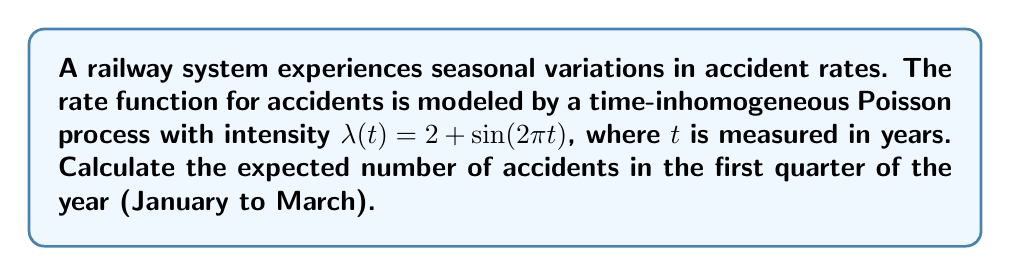What is the answer to this math problem? To solve this problem, we need to follow these steps:

1) In a time-inhomogeneous Poisson process, the expected number of events in an interval $[a,b]$ is given by:

   $$E[N(b) - N(a)] = \int_a^b \lambda(t) dt$$

2) In our case, $a = 0$ (start of the year) and $b = 0.25$ (end of first quarter). So we need to calculate:

   $$E[N(0.25) - N(0)] = \int_0^{0.25} (2 + \sin(2\pi t)) dt$$

3) Let's solve this integral:

   $$\int_0^{0.25} (2 + \sin(2\pi t)) dt = \int_0^{0.25} 2 dt + \int_0^{0.25} \sin(2\pi t) dt$$

4) The first part is straightforward:

   $$\int_0^{0.25} 2 dt = 2t \Big|_0^{0.25} = 2(0.25) - 2(0) = 0.5$$

5) For the second part:

   $$\int_0^{0.25} \sin(2\pi t) dt = -\frac{1}{2\pi} \cos(2\pi t) \Big|_0^{0.25}$$
   $$= -\frac{1}{2\pi} [\cos(2\pi(0.25)) - \cos(2\pi(0))]$$
   $$= -\frac{1}{2\pi} [\cos(\pi/2) - \cos(0)]$$
   $$= -\frac{1}{2\pi} [0 - 1] = \frac{1}{2\pi}$$

6) Adding the results from steps 4 and 5:

   $$E[N(0.25) - N(0)] = 0.5 + \frac{1}{2\pi} \approx 0.6592$$

This is the expected number of accidents in the first quarter of the year.
Answer: 0.6592 